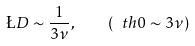<formula> <loc_0><loc_0><loc_500><loc_500>\L D \sim \frac { 1 } { 3 \nu } , \quad ( \ t h 0 \sim 3 \nu )</formula> 